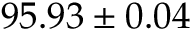Convert formula to latex. <formula><loc_0><loc_0><loc_500><loc_500>9 5 . 9 3 \pm 0 . 0 4</formula> 